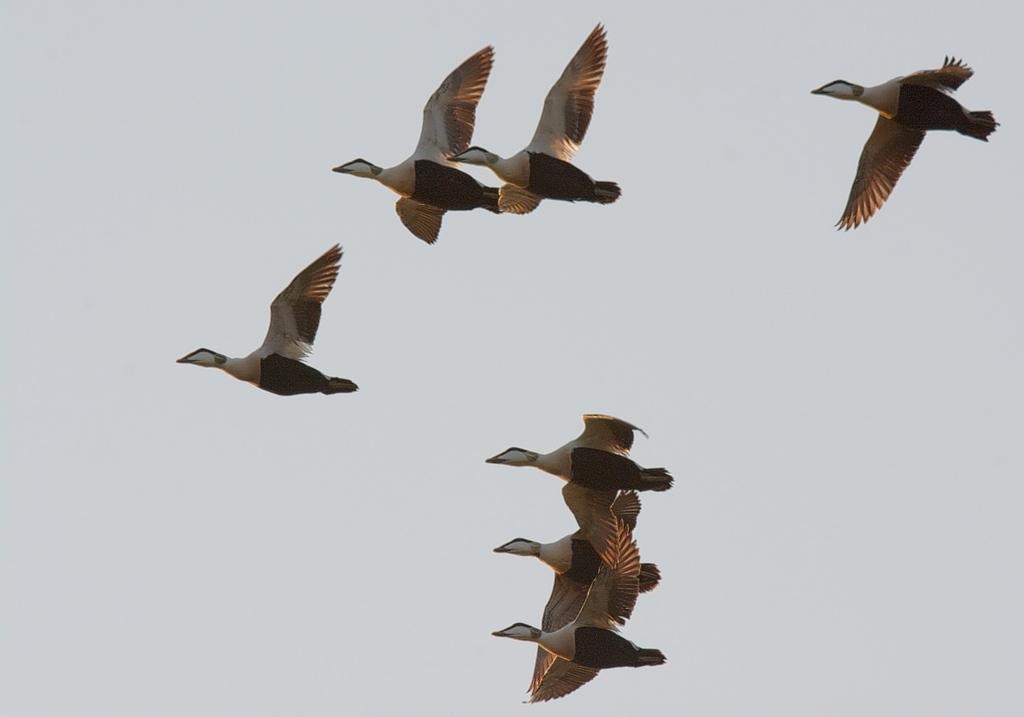Could you give a brief overview of what you see in this image? In this image we can see birds flying in the sky. 